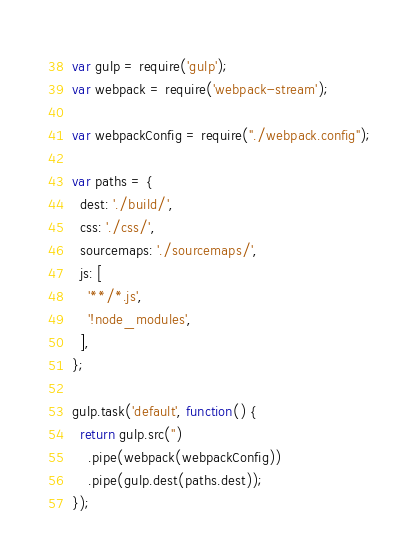<code> <loc_0><loc_0><loc_500><loc_500><_JavaScript_>var gulp = require('gulp');
var webpack = require('webpack-stream');

var webpackConfig = require("./webpack.config");

var paths = {
  dest: './build/',
  css: './css/',
  sourcemaps: './sourcemaps/',
  js: [
    '**/*.js',
    '!node_modules',
  ],
};

gulp.task('default', function() {
  return gulp.src('')
    .pipe(webpack(webpackConfig))
    .pipe(gulp.dest(paths.dest));
});


</code> 